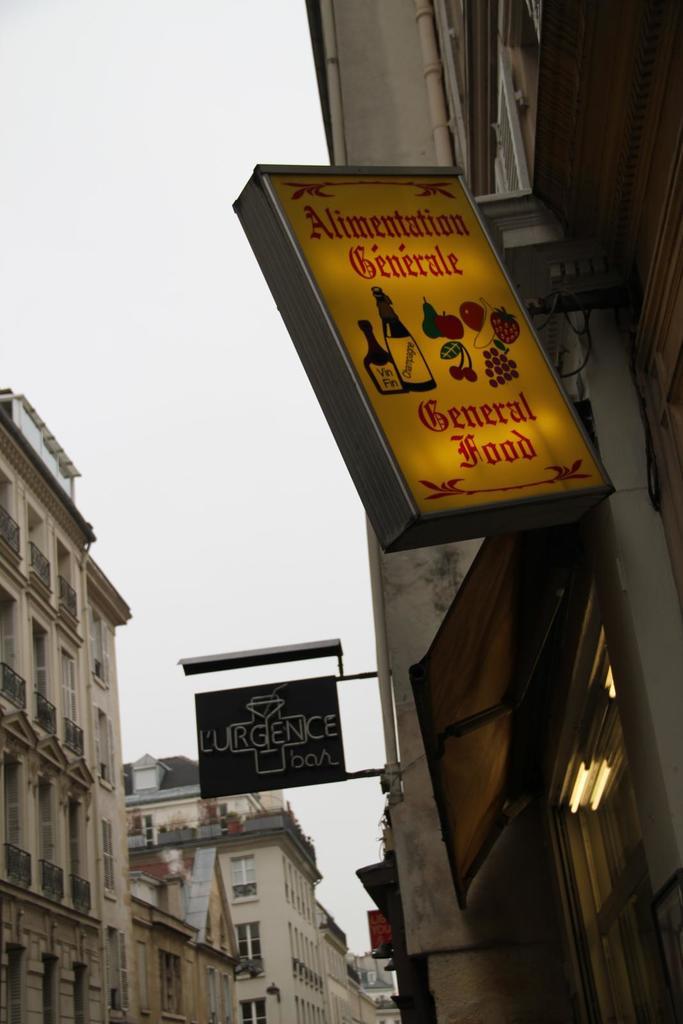Do either of these signs have "general food" on them?
Your answer should be compact. Yes. 